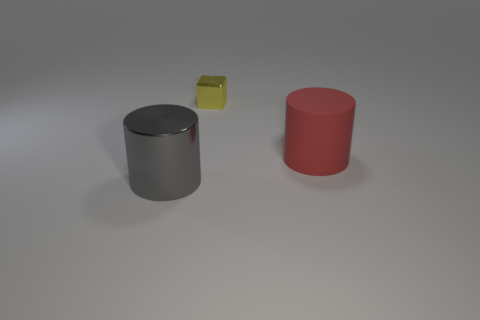Are there any red objects left of the cylinder left of the red object?
Your answer should be compact. No. Are there any other things that are made of the same material as the tiny object?
Provide a short and direct response. Yes. There is a large shiny object; is it the same shape as the metallic object that is to the right of the gray object?
Ensure brevity in your answer.  No. How many other things are the same size as the yellow metal cube?
Your answer should be very brief. 0. How many blue things are small objects or rubber cylinders?
Offer a terse response. 0. What number of things are both in front of the yellow block and to the left of the big red cylinder?
Offer a terse response. 1. There is a large cylinder that is behind the big cylinder that is in front of the big red cylinder to the right of the tiny metallic block; what is its material?
Offer a very short reply. Rubber. What number of red cylinders have the same material as the red thing?
Give a very brief answer. 0. What is the shape of the gray metal thing that is the same size as the red matte object?
Offer a terse response. Cylinder. Are there any gray metallic cylinders right of the big gray cylinder?
Offer a terse response. No. 